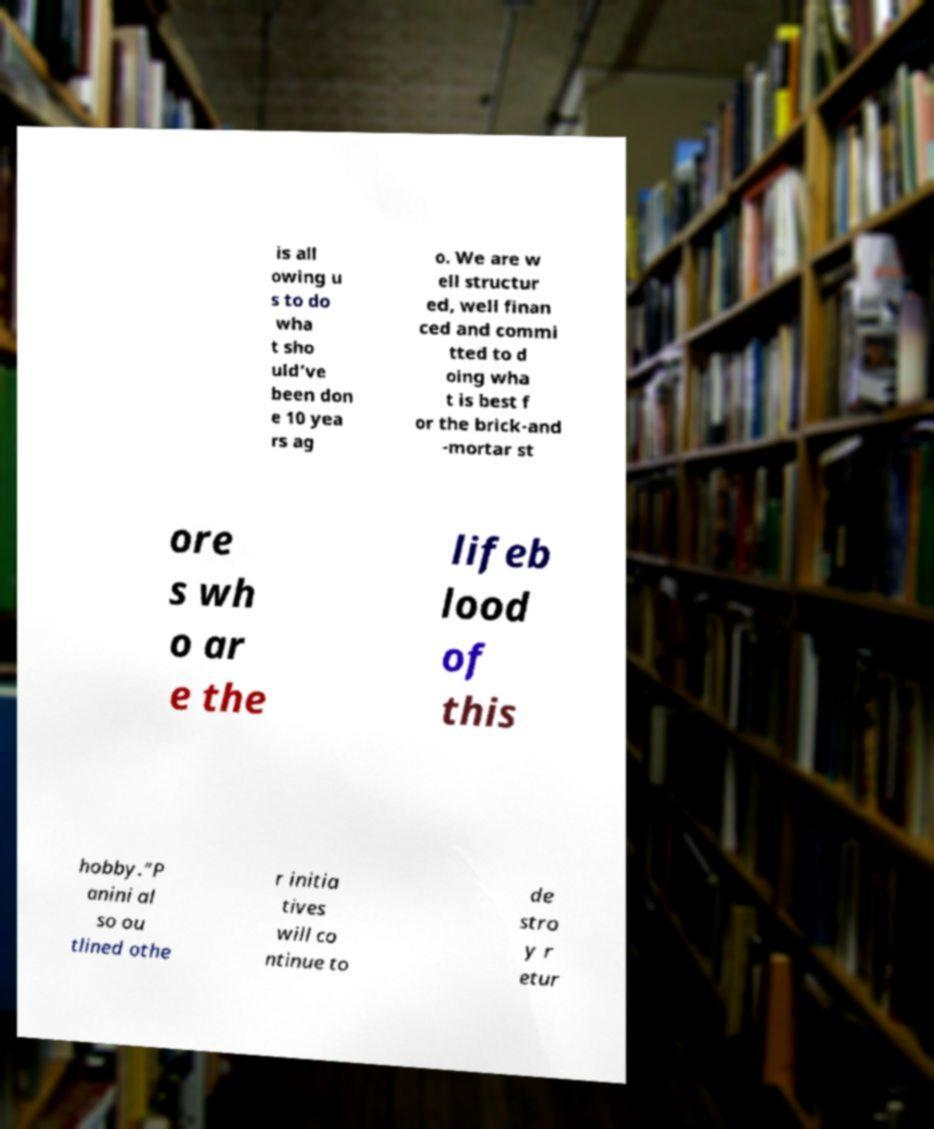For documentation purposes, I need the text within this image transcribed. Could you provide that? is all owing u s to do wha t sho uld’ve been don e 10 yea rs ag o. We are w ell structur ed, well finan ced and commi tted to d oing wha t is best f or the brick-and -mortar st ore s wh o ar e the lifeb lood of this hobby.”P anini al so ou tlined othe r initia tives will co ntinue to de stro y r etur 